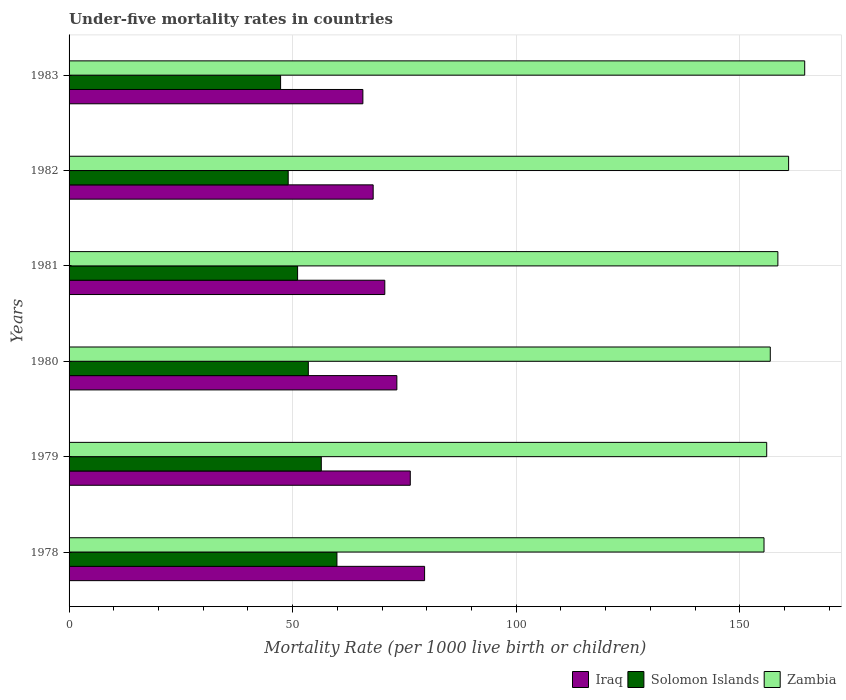How many groups of bars are there?
Ensure brevity in your answer.  6. What is the label of the 1st group of bars from the top?
Offer a terse response. 1983. In how many cases, is the number of bars for a given year not equal to the number of legend labels?
Ensure brevity in your answer.  0. Across all years, what is the maximum under-five mortality rate in Zambia?
Keep it short and to the point. 164.5. Across all years, what is the minimum under-five mortality rate in Solomon Islands?
Your response must be concise. 47.3. In which year was the under-five mortality rate in Iraq maximum?
Offer a terse response. 1978. In which year was the under-five mortality rate in Iraq minimum?
Make the answer very short. 1983. What is the total under-five mortality rate in Zambia in the graph?
Your answer should be very brief. 952.1. What is the difference between the under-five mortality rate in Iraq in 1982 and that in 1983?
Keep it short and to the point. 2.3. What is the difference between the under-five mortality rate in Iraq in 1980 and the under-five mortality rate in Solomon Islands in 1982?
Offer a terse response. 24.3. What is the average under-five mortality rate in Zambia per year?
Your response must be concise. 158.68. In the year 1983, what is the difference between the under-five mortality rate in Iraq and under-five mortality rate in Solomon Islands?
Keep it short and to the point. 18.4. What is the ratio of the under-five mortality rate in Solomon Islands in 1980 to that in 1981?
Offer a very short reply. 1.05. What is the difference between the highest and the lowest under-five mortality rate in Iraq?
Ensure brevity in your answer.  13.8. In how many years, is the under-five mortality rate in Zambia greater than the average under-five mortality rate in Zambia taken over all years?
Keep it short and to the point. 2. Is the sum of the under-five mortality rate in Iraq in 1980 and 1982 greater than the maximum under-five mortality rate in Zambia across all years?
Keep it short and to the point. No. What does the 3rd bar from the top in 1982 represents?
Ensure brevity in your answer.  Iraq. What does the 1st bar from the bottom in 1983 represents?
Provide a succinct answer. Iraq. Is it the case that in every year, the sum of the under-five mortality rate in Solomon Islands and under-five mortality rate in Iraq is greater than the under-five mortality rate in Zambia?
Provide a short and direct response. No. How many bars are there?
Provide a short and direct response. 18. Are all the bars in the graph horizontal?
Provide a succinct answer. Yes. How many years are there in the graph?
Your answer should be very brief. 6. What is the difference between two consecutive major ticks on the X-axis?
Ensure brevity in your answer.  50. Does the graph contain any zero values?
Offer a very short reply. No. Does the graph contain grids?
Make the answer very short. Yes. How are the legend labels stacked?
Provide a short and direct response. Horizontal. What is the title of the graph?
Your response must be concise. Under-five mortality rates in countries. What is the label or title of the X-axis?
Provide a succinct answer. Mortality Rate (per 1000 live birth or children). What is the Mortality Rate (per 1000 live birth or children) in Iraq in 1978?
Provide a succinct answer. 79.5. What is the Mortality Rate (per 1000 live birth or children) in Solomon Islands in 1978?
Provide a short and direct response. 59.9. What is the Mortality Rate (per 1000 live birth or children) of Zambia in 1978?
Make the answer very short. 155.4. What is the Mortality Rate (per 1000 live birth or children) in Iraq in 1979?
Ensure brevity in your answer.  76.3. What is the Mortality Rate (per 1000 live birth or children) in Solomon Islands in 1979?
Offer a terse response. 56.4. What is the Mortality Rate (per 1000 live birth or children) in Zambia in 1979?
Your answer should be compact. 156. What is the Mortality Rate (per 1000 live birth or children) of Iraq in 1980?
Offer a very short reply. 73.3. What is the Mortality Rate (per 1000 live birth or children) in Solomon Islands in 1980?
Make the answer very short. 53.5. What is the Mortality Rate (per 1000 live birth or children) in Zambia in 1980?
Keep it short and to the point. 156.8. What is the Mortality Rate (per 1000 live birth or children) of Iraq in 1981?
Offer a terse response. 70.6. What is the Mortality Rate (per 1000 live birth or children) of Solomon Islands in 1981?
Your answer should be very brief. 51.1. What is the Mortality Rate (per 1000 live birth or children) in Zambia in 1981?
Your answer should be compact. 158.5. What is the Mortality Rate (per 1000 live birth or children) in Solomon Islands in 1982?
Provide a short and direct response. 49. What is the Mortality Rate (per 1000 live birth or children) of Zambia in 1982?
Make the answer very short. 160.9. What is the Mortality Rate (per 1000 live birth or children) of Iraq in 1983?
Give a very brief answer. 65.7. What is the Mortality Rate (per 1000 live birth or children) of Solomon Islands in 1983?
Give a very brief answer. 47.3. What is the Mortality Rate (per 1000 live birth or children) of Zambia in 1983?
Offer a very short reply. 164.5. Across all years, what is the maximum Mortality Rate (per 1000 live birth or children) in Iraq?
Your answer should be very brief. 79.5. Across all years, what is the maximum Mortality Rate (per 1000 live birth or children) in Solomon Islands?
Give a very brief answer. 59.9. Across all years, what is the maximum Mortality Rate (per 1000 live birth or children) of Zambia?
Provide a succinct answer. 164.5. Across all years, what is the minimum Mortality Rate (per 1000 live birth or children) in Iraq?
Offer a very short reply. 65.7. Across all years, what is the minimum Mortality Rate (per 1000 live birth or children) in Solomon Islands?
Your response must be concise. 47.3. Across all years, what is the minimum Mortality Rate (per 1000 live birth or children) in Zambia?
Ensure brevity in your answer.  155.4. What is the total Mortality Rate (per 1000 live birth or children) of Iraq in the graph?
Provide a short and direct response. 433.4. What is the total Mortality Rate (per 1000 live birth or children) of Solomon Islands in the graph?
Provide a succinct answer. 317.2. What is the total Mortality Rate (per 1000 live birth or children) in Zambia in the graph?
Provide a succinct answer. 952.1. What is the difference between the Mortality Rate (per 1000 live birth or children) in Zambia in 1978 and that in 1979?
Give a very brief answer. -0.6. What is the difference between the Mortality Rate (per 1000 live birth or children) of Iraq in 1978 and that in 1980?
Provide a short and direct response. 6.2. What is the difference between the Mortality Rate (per 1000 live birth or children) in Solomon Islands in 1978 and that in 1980?
Offer a terse response. 6.4. What is the difference between the Mortality Rate (per 1000 live birth or children) of Zambia in 1978 and that in 1980?
Your answer should be very brief. -1.4. What is the difference between the Mortality Rate (per 1000 live birth or children) of Iraq in 1978 and that in 1982?
Make the answer very short. 11.5. What is the difference between the Mortality Rate (per 1000 live birth or children) in Zambia in 1978 and that in 1982?
Ensure brevity in your answer.  -5.5. What is the difference between the Mortality Rate (per 1000 live birth or children) in Iraq in 1978 and that in 1983?
Ensure brevity in your answer.  13.8. What is the difference between the Mortality Rate (per 1000 live birth or children) in Solomon Islands in 1978 and that in 1983?
Make the answer very short. 12.6. What is the difference between the Mortality Rate (per 1000 live birth or children) in Zambia in 1978 and that in 1983?
Give a very brief answer. -9.1. What is the difference between the Mortality Rate (per 1000 live birth or children) in Iraq in 1979 and that in 1980?
Offer a terse response. 3. What is the difference between the Mortality Rate (per 1000 live birth or children) in Solomon Islands in 1979 and that in 1980?
Make the answer very short. 2.9. What is the difference between the Mortality Rate (per 1000 live birth or children) of Zambia in 1979 and that in 1980?
Offer a very short reply. -0.8. What is the difference between the Mortality Rate (per 1000 live birth or children) in Iraq in 1979 and that in 1981?
Offer a very short reply. 5.7. What is the difference between the Mortality Rate (per 1000 live birth or children) in Iraq in 1979 and that in 1982?
Offer a terse response. 8.3. What is the difference between the Mortality Rate (per 1000 live birth or children) of Zambia in 1979 and that in 1982?
Offer a very short reply. -4.9. What is the difference between the Mortality Rate (per 1000 live birth or children) in Solomon Islands in 1979 and that in 1983?
Your response must be concise. 9.1. What is the difference between the Mortality Rate (per 1000 live birth or children) in Iraq in 1980 and that in 1981?
Ensure brevity in your answer.  2.7. What is the difference between the Mortality Rate (per 1000 live birth or children) of Solomon Islands in 1980 and that in 1981?
Offer a terse response. 2.4. What is the difference between the Mortality Rate (per 1000 live birth or children) in Zambia in 1980 and that in 1981?
Keep it short and to the point. -1.7. What is the difference between the Mortality Rate (per 1000 live birth or children) in Iraq in 1981 and that in 1982?
Provide a succinct answer. 2.6. What is the difference between the Mortality Rate (per 1000 live birth or children) of Solomon Islands in 1981 and that in 1982?
Make the answer very short. 2.1. What is the difference between the Mortality Rate (per 1000 live birth or children) of Zambia in 1981 and that in 1982?
Provide a succinct answer. -2.4. What is the difference between the Mortality Rate (per 1000 live birth or children) of Iraq in 1981 and that in 1983?
Provide a succinct answer. 4.9. What is the difference between the Mortality Rate (per 1000 live birth or children) of Solomon Islands in 1981 and that in 1983?
Your answer should be very brief. 3.8. What is the difference between the Mortality Rate (per 1000 live birth or children) of Iraq in 1982 and that in 1983?
Offer a terse response. 2.3. What is the difference between the Mortality Rate (per 1000 live birth or children) in Solomon Islands in 1982 and that in 1983?
Ensure brevity in your answer.  1.7. What is the difference between the Mortality Rate (per 1000 live birth or children) of Iraq in 1978 and the Mortality Rate (per 1000 live birth or children) of Solomon Islands in 1979?
Keep it short and to the point. 23.1. What is the difference between the Mortality Rate (per 1000 live birth or children) of Iraq in 1978 and the Mortality Rate (per 1000 live birth or children) of Zambia in 1979?
Give a very brief answer. -76.5. What is the difference between the Mortality Rate (per 1000 live birth or children) of Solomon Islands in 1978 and the Mortality Rate (per 1000 live birth or children) of Zambia in 1979?
Keep it short and to the point. -96.1. What is the difference between the Mortality Rate (per 1000 live birth or children) in Iraq in 1978 and the Mortality Rate (per 1000 live birth or children) in Zambia in 1980?
Your answer should be very brief. -77.3. What is the difference between the Mortality Rate (per 1000 live birth or children) of Solomon Islands in 1978 and the Mortality Rate (per 1000 live birth or children) of Zambia in 1980?
Offer a terse response. -96.9. What is the difference between the Mortality Rate (per 1000 live birth or children) of Iraq in 1978 and the Mortality Rate (per 1000 live birth or children) of Solomon Islands in 1981?
Your answer should be compact. 28.4. What is the difference between the Mortality Rate (per 1000 live birth or children) in Iraq in 1978 and the Mortality Rate (per 1000 live birth or children) in Zambia in 1981?
Offer a very short reply. -79. What is the difference between the Mortality Rate (per 1000 live birth or children) in Solomon Islands in 1978 and the Mortality Rate (per 1000 live birth or children) in Zambia in 1981?
Make the answer very short. -98.6. What is the difference between the Mortality Rate (per 1000 live birth or children) in Iraq in 1978 and the Mortality Rate (per 1000 live birth or children) in Solomon Islands in 1982?
Make the answer very short. 30.5. What is the difference between the Mortality Rate (per 1000 live birth or children) in Iraq in 1978 and the Mortality Rate (per 1000 live birth or children) in Zambia in 1982?
Your answer should be very brief. -81.4. What is the difference between the Mortality Rate (per 1000 live birth or children) in Solomon Islands in 1978 and the Mortality Rate (per 1000 live birth or children) in Zambia in 1982?
Keep it short and to the point. -101. What is the difference between the Mortality Rate (per 1000 live birth or children) in Iraq in 1978 and the Mortality Rate (per 1000 live birth or children) in Solomon Islands in 1983?
Make the answer very short. 32.2. What is the difference between the Mortality Rate (per 1000 live birth or children) of Iraq in 1978 and the Mortality Rate (per 1000 live birth or children) of Zambia in 1983?
Your answer should be very brief. -85. What is the difference between the Mortality Rate (per 1000 live birth or children) in Solomon Islands in 1978 and the Mortality Rate (per 1000 live birth or children) in Zambia in 1983?
Keep it short and to the point. -104.6. What is the difference between the Mortality Rate (per 1000 live birth or children) of Iraq in 1979 and the Mortality Rate (per 1000 live birth or children) of Solomon Islands in 1980?
Provide a short and direct response. 22.8. What is the difference between the Mortality Rate (per 1000 live birth or children) of Iraq in 1979 and the Mortality Rate (per 1000 live birth or children) of Zambia in 1980?
Your answer should be compact. -80.5. What is the difference between the Mortality Rate (per 1000 live birth or children) of Solomon Islands in 1979 and the Mortality Rate (per 1000 live birth or children) of Zambia in 1980?
Your response must be concise. -100.4. What is the difference between the Mortality Rate (per 1000 live birth or children) of Iraq in 1979 and the Mortality Rate (per 1000 live birth or children) of Solomon Islands in 1981?
Provide a succinct answer. 25.2. What is the difference between the Mortality Rate (per 1000 live birth or children) of Iraq in 1979 and the Mortality Rate (per 1000 live birth or children) of Zambia in 1981?
Offer a terse response. -82.2. What is the difference between the Mortality Rate (per 1000 live birth or children) of Solomon Islands in 1979 and the Mortality Rate (per 1000 live birth or children) of Zambia in 1981?
Your answer should be very brief. -102.1. What is the difference between the Mortality Rate (per 1000 live birth or children) in Iraq in 1979 and the Mortality Rate (per 1000 live birth or children) in Solomon Islands in 1982?
Offer a terse response. 27.3. What is the difference between the Mortality Rate (per 1000 live birth or children) of Iraq in 1979 and the Mortality Rate (per 1000 live birth or children) of Zambia in 1982?
Your response must be concise. -84.6. What is the difference between the Mortality Rate (per 1000 live birth or children) of Solomon Islands in 1979 and the Mortality Rate (per 1000 live birth or children) of Zambia in 1982?
Provide a short and direct response. -104.5. What is the difference between the Mortality Rate (per 1000 live birth or children) of Iraq in 1979 and the Mortality Rate (per 1000 live birth or children) of Zambia in 1983?
Provide a short and direct response. -88.2. What is the difference between the Mortality Rate (per 1000 live birth or children) in Solomon Islands in 1979 and the Mortality Rate (per 1000 live birth or children) in Zambia in 1983?
Keep it short and to the point. -108.1. What is the difference between the Mortality Rate (per 1000 live birth or children) in Iraq in 1980 and the Mortality Rate (per 1000 live birth or children) in Solomon Islands in 1981?
Your answer should be compact. 22.2. What is the difference between the Mortality Rate (per 1000 live birth or children) in Iraq in 1980 and the Mortality Rate (per 1000 live birth or children) in Zambia in 1981?
Make the answer very short. -85.2. What is the difference between the Mortality Rate (per 1000 live birth or children) in Solomon Islands in 1980 and the Mortality Rate (per 1000 live birth or children) in Zambia in 1981?
Offer a very short reply. -105. What is the difference between the Mortality Rate (per 1000 live birth or children) of Iraq in 1980 and the Mortality Rate (per 1000 live birth or children) of Solomon Islands in 1982?
Give a very brief answer. 24.3. What is the difference between the Mortality Rate (per 1000 live birth or children) of Iraq in 1980 and the Mortality Rate (per 1000 live birth or children) of Zambia in 1982?
Give a very brief answer. -87.6. What is the difference between the Mortality Rate (per 1000 live birth or children) in Solomon Islands in 1980 and the Mortality Rate (per 1000 live birth or children) in Zambia in 1982?
Your response must be concise. -107.4. What is the difference between the Mortality Rate (per 1000 live birth or children) of Iraq in 1980 and the Mortality Rate (per 1000 live birth or children) of Zambia in 1983?
Offer a terse response. -91.2. What is the difference between the Mortality Rate (per 1000 live birth or children) of Solomon Islands in 1980 and the Mortality Rate (per 1000 live birth or children) of Zambia in 1983?
Provide a short and direct response. -111. What is the difference between the Mortality Rate (per 1000 live birth or children) of Iraq in 1981 and the Mortality Rate (per 1000 live birth or children) of Solomon Islands in 1982?
Offer a terse response. 21.6. What is the difference between the Mortality Rate (per 1000 live birth or children) of Iraq in 1981 and the Mortality Rate (per 1000 live birth or children) of Zambia in 1982?
Offer a terse response. -90.3. What is the difference between the Mortality Rate (per 1000 live birth or children) in Solomon Islands in 1981 and the Mortality Rate (per 1000 live birth or children) in Zambia in 1982?
Provide a short and direct response. -109.8. What is the difference between the Mortality Rate (per 1000 live birth or children) of Iraq in 1981 and the Mortality Rate (per 1000 live birth or children) of Solomon Islands in 1983?
Give a very brief answer. 23.3. What is the difference between the Mortality Rate (per 1000 live birth or children) of Iraq in 1981 and the Mortality Rate (per 1000 live birth or children) of Zambia in 1983?
Give a very brief answer. -93.9. What is the difference between the Mortality Rate (per 1000 live birth or children) in Solomon Islands in 1981 and the Mortality Rate (per 1000 live birth or children) in Zambia in 1983?
Your answer should be compact. -113.4. What is the difference between the Mortality Rate (per 1000 live birth or children) in Iraq in 1982 and the Mortality Rate (per 1000 live birth or children) in Solomon Islands in 1983?
Provide a succinct answer. 20.7. What is the difference between the Mortality Rate (per 1000 live birth or children) in Iraq in 1982 and the Mortality Rate (per 1000 live birth or children) in Zambia in 1983?
Your response must be concise. -96.5. What is the difference between the Mortality Rate (per 1000 live birth or children) in Solomon Islands in 1982 and the Mortality Rate (per 1000 live birth or children) in Zambia in 1983?
Your response must be concise. -115.5. What is the average Mortality Rate (per 1000 live birth or children) in Iraq per year?
Provide a short and direct response. 72.23. What is the average Mortality Rate (per 1000 live birth or children) of Solomon Islands per year?
Provide a succinct answer. 52.87. What is the average Mortality Rate (per 1000 live birth or children) in Zambia per year?
Make the answer very short. 158.68. In the year 1978, what is the difference between the Mortality Rate (per 1000 live birth or children) of Iraq and Mortality Rate (per 1000 live birth or children) of Solomon Islands?
Provide a short and direct response. 19.6. In the year 1978, what is the difference between the Mortality Rate (per 1000 live birth or children) of Iraq and Mortality Rate (per 1000 live birth or children) of Zambia?
Ensure brevity in your answer.  -75.9. In the year 1978, what is the difference between the Mortality Rate (per 1000 live birth or children) in Solomon Islands and Mortality Rate (per 1000 live birth or children) in Zambia?
Give a very brief answer. -95.5. In the year 1979, what is the difference between the Mortality Rate (per 1000 live birth or children) of Iraq and Mortality Rate (per 1000 live birth or children) of Solomon Islands?
Provide a short and direct response. 19.9. In the year 1979, what is the difference between the Mortality Rate (per 1000 live birth or children) in Iraq and Mortality Rate (per 1000 live birth or children) in Zambia?
Provide a succinct answer. -79.7. In the year 1979, what is the difference between the Mortality Rate (per 1000 live birth or children) in Solomon Islands and Mortality Rate (per 1000 live birth or children) in Zambia?
Offer a very short reply. -99.6. In the year 1980, what is the difference between the Mortality Rate (per 1000 live birth or children) of Iraq and Mortality Rate (per 1000 live birth or children) of Solomon Islands?
Ensure brevity in your answer.  19.8. In the year 1980, what is the difference between the Mortality Rate (per 1000 live birth or children) in Iraq and Mortality Rate (per 1000 live birth or children) in Zambia?
Offer a terse response. -83.5. In the year 1980, what is the difference between the Mortality Rate (per 1000 live birth or children) in Solomon Islands and Mortality Rate (per 1000 live birth or children) in Zambia?
Offer a very short reply. -103.3. In the year 1981, what is the difference between the Mortality Rate (per 1000 live birth or children) of Iraq and Mortality Rate (per 1000 live birth or children) of Zambia?
Keep it short and to the point. -87.9. In the year 1981, what is the difference between the Mortality Rate (per 1000 live birth or children) in Solomon Islands and Mortality Rate (per 1000 live birth or children) in Zambia?
Keep it short and to the point. -107.4. In the year 1982, what is the difference between the Mortality Rate (per 1000 live birth or children) of Iraq and Mortality Rate (per 1000 live birth or children) of Solomon Islands?
Ensure brevity in your answer.  19. In the year 1982, what is the difference between the Mortality Rate (per 1000 live birth or children) of Iraq and Mortality Rate (per 1000 live birth or children) of Zambia?
Make the answer very short. -92.9. In the year 1982, what is the difference between the Mortality Rate (per 1000 live birth or children) of Solomon Islands and Mortality Rate (per 1000 live birth or children) of Zambia?
Your answer should be very brief. -111.9. In the year 1983, what is the difference between the Mortality Rate (per 1000 live birth or children) in Iraq and Mortality Rate (per 1000 live birth or children) in Solomon Islands?
Your answer should be compact. 18.4. In the year 1983, what is the difference between the Mortality Rate (per 1000 live birth or children) in Iraq and Mortality Rate (per 1000 live birth or children) in Zambia?
Offer a very short reply. -98.8. In the year 1983, what is the difference between the Mortality Rate (per 1000 live birth or children) of Solomon Islands and Mortality Rate (per 1000 live birth or children) of Zambia?
Your answer should be compact. -117.2. What is the ratio of the Mortality Rate (per 1000 live birth or children) in Iraq in 1978 to that in 1979?
Provide a short and direct response. 1.04. What is the ratio of the Mortality Rate (per 1000 live birth or children) of Solomon Islands in 1978 to that in 1979?
Provide a succinct answer. 1.06. What is the ratio of the Mortality Rate (per 1000 live birth or children) of Zambia in 1978 to that in 1979?
Offer a very short reply. 1. What is the ratio of the Mortality Rate (per 1000 live birth or children) in Iraq in 1978 to that in 1980?
Ensure brevity in your answer.  1.08. What is the ratio of the Mortality Rate (per 1000 live birth or children) in Solomon Islands in 1978 to that in 1980?
Offer a very short reply. 1.12. What is the ratio of the Mortality Rate (per 1000 live birth or children) in Zambia in 1978 to that in 1980?
Offer a terse response. 0.99. What is the ratio of the Mortality Rate (per 1000 live birth or children) in Iraq in 1978 to that in 1981?
Provide a short and direct response. 1.13. What is the ratio of the Mortality Rate (per 1000 live birth or children) in Solomon Islands in 1978 to that in 1981?
Give a very brief answer. 1.17. What is the ratio of the Mortality Rate (per 1000 live birth or children) of Zambia in 1978 to that in 1981?
Your answer should be very brief. 0.98. What is the ratio of the Mortality Rate (per 1000 live birth or children) of Iraq in 1978 to that in 1982?
Keep it short and to the point. 1.17. What is the ratio of the Mortality Rate (per 1000 live birth or children) in Solomon Islands in 1978 to that in 1982?
Offer a very short reply. 1.22. What is the ratio of the Mortality Rate (per 1000 live birth or children) of Zambia in 1978 to that in 1982?
Your answer should be compact. 0.97. What is the ratio of the Mortality Rate (per 1000 live birth or children) in Iraq in 1978 to that in 1983?
Provide a short and direct response. 1.21. What is the ratio of the Mortality Rate (per 1000 live birth or children) in Solomon Islands in 1978 to that in 1983?
Make the answer very short. 1.27. What is the ratio of the Mortality Rate (per 1000 live birth or children) of Zambia in 1978 to that in 1983?
Your answer should be compact. 0.94. What is the ratio of the Mortality Rate (per 1000 live birth or children) of Iraq in 1979 to that in 1980?
Provide a succinct answer. 1.04. What is the ratio of the Mortality Rate (per 1000 live birth or children) of Solomon Islands in 1979 to that in 1980?
Your response must be concise. 1.05. What is the ratio of the Mortality Rate (per 1000 live birth or children) of Iraq in 1979 to that in 1981?
Your response must be concise. 1.08. What is the ratio of the Mortality Rate (per 1000 live birth or children) in Solomon Islands in 1979 to that in 1981?
Provide a succinct answer. 1.1. What is the ratio of the Mortality Rate (per 1000 live birth or children) of Zambia in 1979 to that in 1981?
Your response must be concise. 0.98. What is the ratio of the Mortality Rate (per 1000 live birth or children) of Iraq in 1979 to that in 1982?
Provide a short and direct response. 1.12. What is the ratio of the Mortality Rate (per 1000 live birth or children) in Solomon Islands in 1979 to that in 1982?
Keep it short and to the point. 1.15. What is the ratio of the Mortality Rate (per 1000 live birth or children) of Zambia in 1979 to that in 1982?
Offer a terse response. 0.97. What is the ratio of the Mortality Rate (per 1000 live birth or children) in Iraq in 1979 to that in 1983?
Offer a terse response. 1.16. What is the ratio of the Mortality Rate (per 1000 live birth or children) in Solomon Islands in 1979 to that in 1983?
Ensure brevity in your answer.  1.19. What is the ratio of the Mortality Rate (per 1000 live birth or children) in Zambia in 1979 to that in 1983?
Provide a succinct answer. 0.95. What is the ratio of the Mortality Rate (per 1000 live birth or children) of Iraq in 1980 to that in 1981?
Offer a very short reply. 1.04. What is the ratio of the Mortality Rate (per 1000 live birth or children) of Solomon Islands in 1980 to that in 1981?
Your response must be concise. 1.05. What is the ratio of the Mortality Rate (per 1000 live birth or children) in Zambia in 1980 to that in 1981?
Your response must be concise. 0.99. What is the ratio of the Mortality Rate (per 1000 live birth or children) in Iraq in 1980 to that in 1982?
Give a very brief answer. 1.08. What is the ratio of the Mortality Rate (per 1000 live birth or children) in Solomon Islands in 1980 to that in 1982?
Provide a succinct answer. 1.09. What is the ratio of the Mortality Rate (per 1000 live birth or children) of Zambia in 1980 to that in 1982?
Give a very brief answer. 0.97. What is the ratio of the Mortality Rate (per 1000 live birth or children) of Iraq in 1980 to that in 1983?
Make the answer very short. 1.12. What is the ratio of the Mortality Rate (per 1000 live birth or children) of Solomon Islands in 1980 to that in 1983?
Your answer should be very brief. 1.13. What is the ratio of the Mortality Rate (per 1000 live birth or children) in Zambia in 1980 to that in 1983?
Keep it short and to the point. 0.95. What is the ratio of the Mortality Rate (per 1000 live birth or children) in Iraq in 1981 to that in 1982?
Provide a succinct answer. 1.04. What is the ratio of the Mortality Rate (per 1000 live birth or children) in Solomon Islands in 1981 to that in 1982?
Provide a succinct answer. 1.04. What is the ratio of the Mortality Rate (per 1000 live birth or children) of Zambia in 1981 to that in 1982?
Provide a succinct answer. 0.99. What is the ratio of the Mortality Rate (per 1000 live birth or children) of Iraq in 1981 to that in 1983?
Give a very brief answer. 1.07. What is the ratio of the Mortality Rate (per 1000 live birth or children) of Solomon Islands in 1981 to that in 1983?
Your answer should be very brief. 1.08. What is the ratio of the Mortality Rate (per 1000 live birth or children) of Zambia in 1981 to that in 1983?
Give a very brief answer. 0.96. What is the ratio of the Mortality Rate (per 1000 live birth or children) in Iraq in 1982 to that in 1983?
Provide a succinct answer. 1.03. What is the ratio of the Mortality Rate (per 1000 live birth or children) in Solomon Islands in 1982 to that in 1983?
Make the answer very short. 1.04. What is the ratio of the Mortality Rate (per 1000 live birth or children) of Zambia in 1982 to that in 1983?
Give a very brief answer. 0.98. What is the difference between the highest and the second highest Mortality Rate (per 1000 live birth or children) in Iraq?
Offer a very short reply. 3.2. What is the difference between the highest and the second highest Mortality Rate (per 1000 live birth or children) in Solomon Islands?
Ensure brevity in your answer.  3.5. What is the difference between the highest and the second highest Mortality Rate (per 1000 live birth or children) in Zambia?
Offer a terse response. 3.6. What is the difference between the highest and the lowest Mortality Rate (per 1000 live birth or children) in Iraq?
Provide a short and direct response. 13.8. What is the difference between the highest and the lowest Mortality Rate (per 1000 live birth or children) in Solomon Islands?
Make the answer very short. 12.6. What is the difference between the highest and the lowest Mortality Rate (per 1000 live birth or children) of Zambia?
Ensure brevity in your answer.  9.1. 